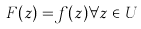Convert formula to latex. <formula><loc_0><loc_0><loc_500><loc_500>F ( z ) = f ( z ) \forall z \in U</formula> 